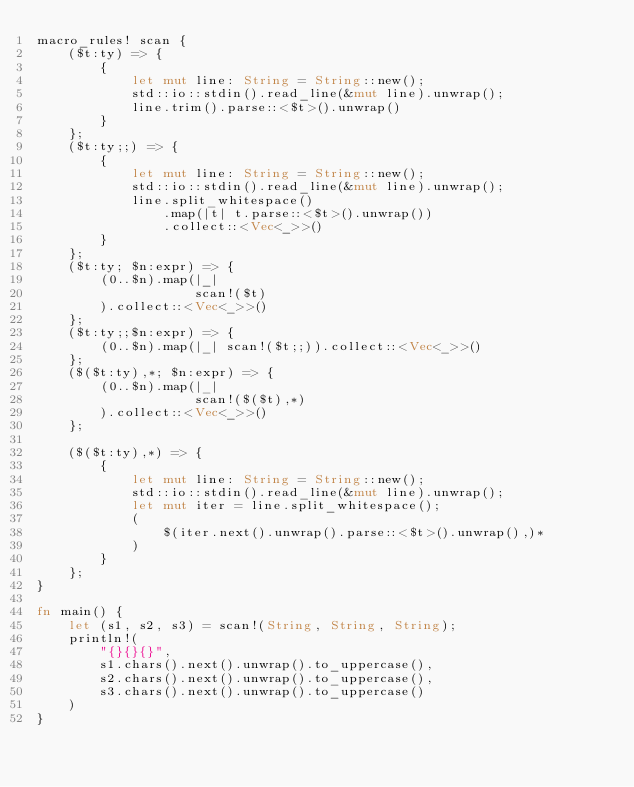<code> <loc_0><loc_0><loc_500><loc_500><_Rust_>macro_rules! scan {
    ($t:ty) => {
        {
            let mut line: String = String::new();
            std::io::stdin().read_line(&mut line).unwrap();
            line.trim().parse::<$t>().unwrap()
        }
    };
    ($t:ty;;) => {
        {
            let mut line: String = String::new();
            std::io::stdin().read_line(&mut line).unwrap();
            line.split_whitespace()
                .map(|t| t.parse::<$t>().unwrap())
                .collect::<Vec<_>>()
        }
    };
    ($t:ty; $n:expr) => {
        (0..$n).map(|_|
                    scan!($t)
        ).collect::<Vec<_>>()
    };
    ($t:ty;;$n:expr) => {
        (0..$n).map(|_| scan!($t;;)).collect::<Vec<_>>()
    };
    ($($t:ty),*; $n:expr) => {
        (0..$n).map(|_|
                    scan!($($t),*)
        ).collect::<Vec<_>>()
    };

    ($($t:ty),*) => {
        {
            let mut line: String = String::new();
            std::io::stdin().read_line(&mut line).unwrap();
            let mut iter = line.split_whitespace();
            (
                $(iter.next().unwrap().parse::<$t>().unwrap(),)*
            )
        }
    };
}

fn main() {
    let (s1, s2, s3) = scan!(String, String, String);
    println!(
        "{}{}{}",
        s1.chars().next().unwrap().to_uppercase(),
        s2.chars().next().unwrap().to_uppercase(),
        s3.chars().next().unwrap().to_uppercase()
    )
}
</code> 